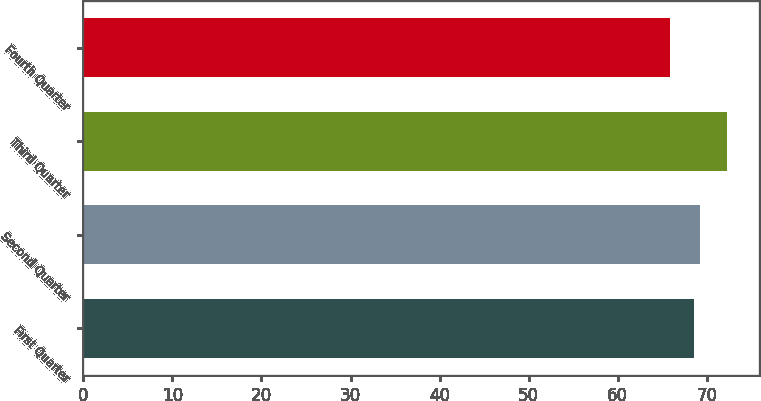<chart> <loc_0><loc_0><loc_500><loc_500><bar_chart><fcel>First Quarter<fcel>Second Quarter<fcel>Third Quarter<fcel>Fourth Quarter<nl><fcel>68.58<fcel>69.22<fcel>72.27<fcel>65.91<nl></chart> 